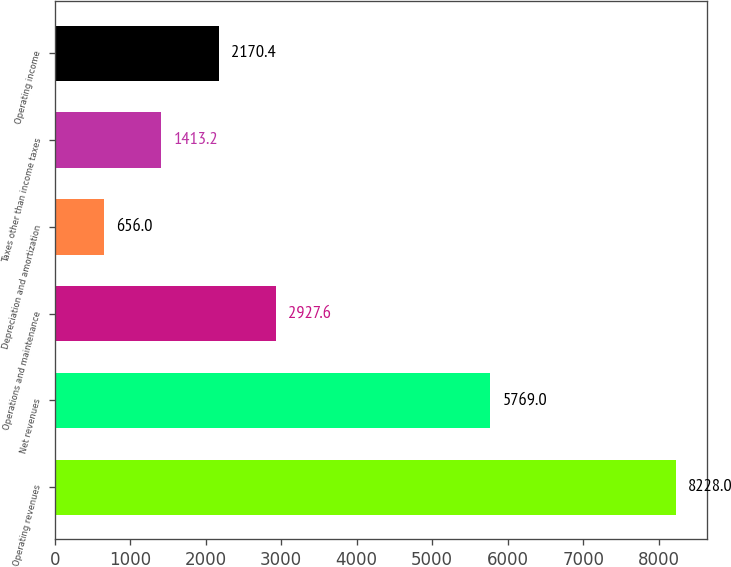Convert chart to OTSL. <chart><loc_0><loc_0><loc_500><loc_500><bar_chart><fcel>Operating revenues<fcel>Net revenues<fcel>Operations and maintenance<fcel>Depreciation and amortization<fcel>Taxes other than income taxes<fcel>Operating income<nl><fcel>8228<fcel>5769<fcel>2927.6<fcel>656<fcel>1413.2<fcel>2170.4<nl></chart> 